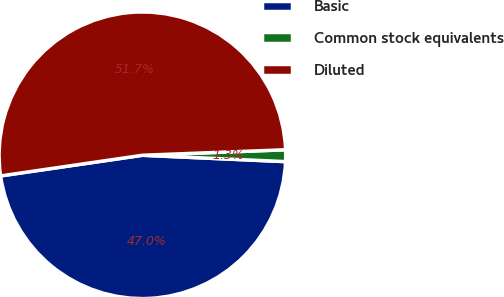Convert chart to OTSL. <chart><loc_0><loc_0><loc_500><loc_500><pie_chart><fcel>Basic<fcel>Common stock equivalents<fcel>Diluted<nl><fcel>46.99%<fcel>1.32%<fcel>51.69%<nl></chart> 